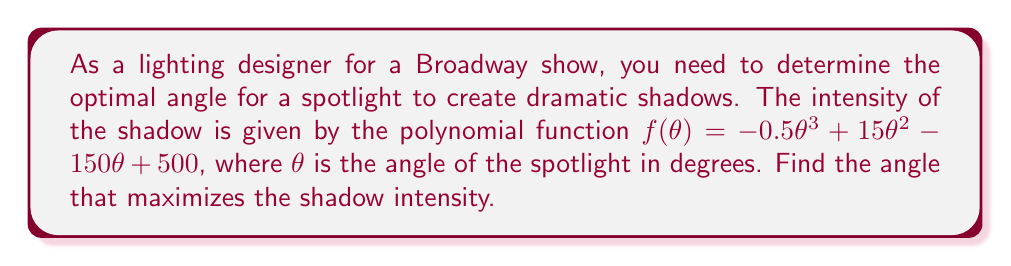What is the answer to this math problem? To find the angle that maximizes the shadow intensity, we need to find the maximum point of the polynomial function. This occurs where the derivative of the function is zero.

1) First, let's find the derivative of $f(\theta)$:
   $f'(\theta) = -1.5\theta^2 + 30\theta - 150$

2) Set the derivative equal to zero:
   $-1.5\theta^2 + 30\theta - 150 = 0$

3) This is a quadratic equation. Let's solve it using the quadratic formula:
   $\theta = \frac{-b \pm \sqrt{b^2 - 4ac}}{2a}$

   Where $a = -1.5$, $b = 30$, and $c = -150$

4) Substituting these values:
   $\theta = \frac{-30 \pm \sqrt{30^2 - 4(-1.5)(-150)}}{2(-1.5)}$

5) Simplifying:
   $\theta = \frac{-30 \pm \sqrt{900 - 900}}{-3} = \frac{-30 \pm 0}{-3} = 10$

6) The second derivative is $f''(\theta) = -3\theta + 30$. At $\theta = 10$, $f''(10) = 0$, which means this is an inflection point.

7) To confirm the maximum, we need to check the values on either side of $\theta = 10$:
   At $\theta = 9$, $f(9) = 500$
   At $\theta = 10$, $f(10) = 500$
   At $\theta = 11$, $f(11) = 499$

Therefore, the maximum occurs at $\theta = 10$ degrees.
Answer: 10 degrees 